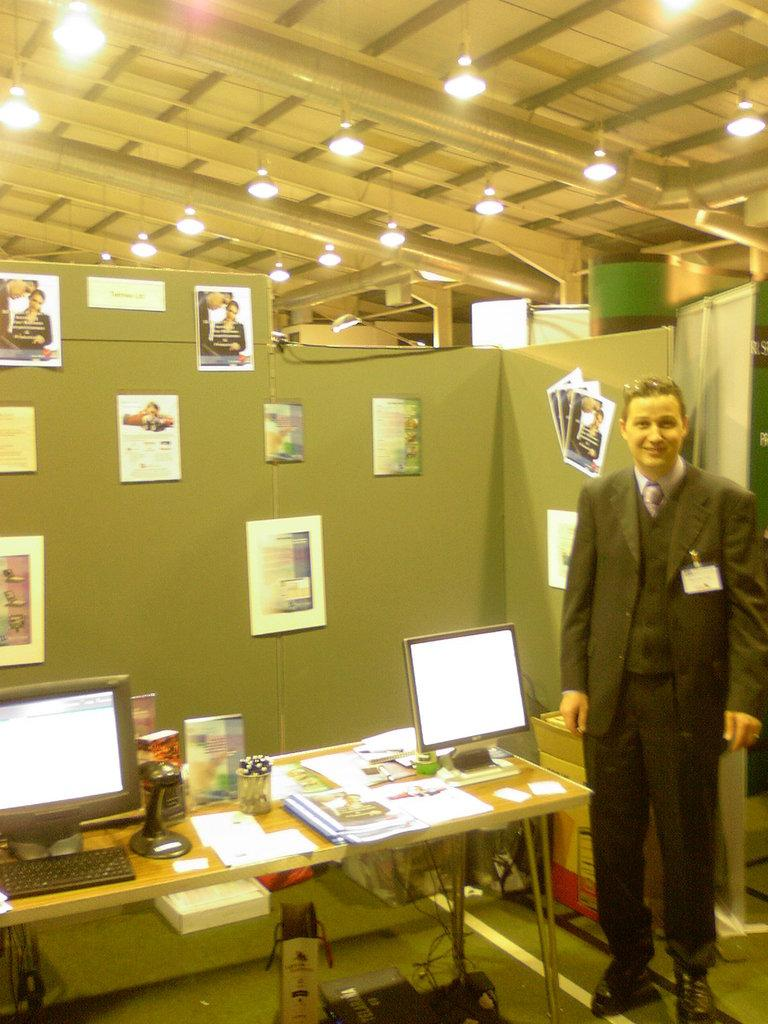What is the person in the image wearing? The person in the image is wearing a suit. Where is the person located in the image? The person is standing at the right side of the image. What can be seen on top of the table in the image? There are systems on the top of a table in the image. What type of decorations are on the wall in the image? There are paintings attached to the wall in the image. What type of chin can be seen on the person in the image? There is no chin visible on the person in the image, as the person is only shown from the waist up. 